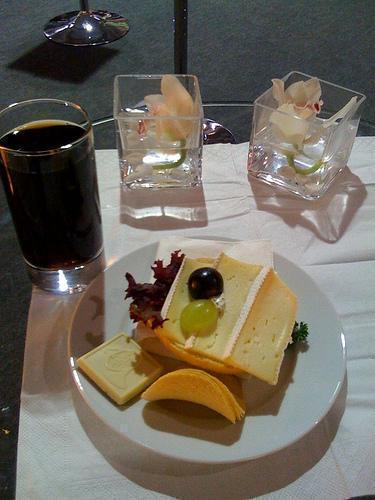What kind of chips are served on the plate?
From the following set of four choices, select the accurate answer to respond to the question.
Options: Doritos, lays, pringles, stacys. Pringles. 